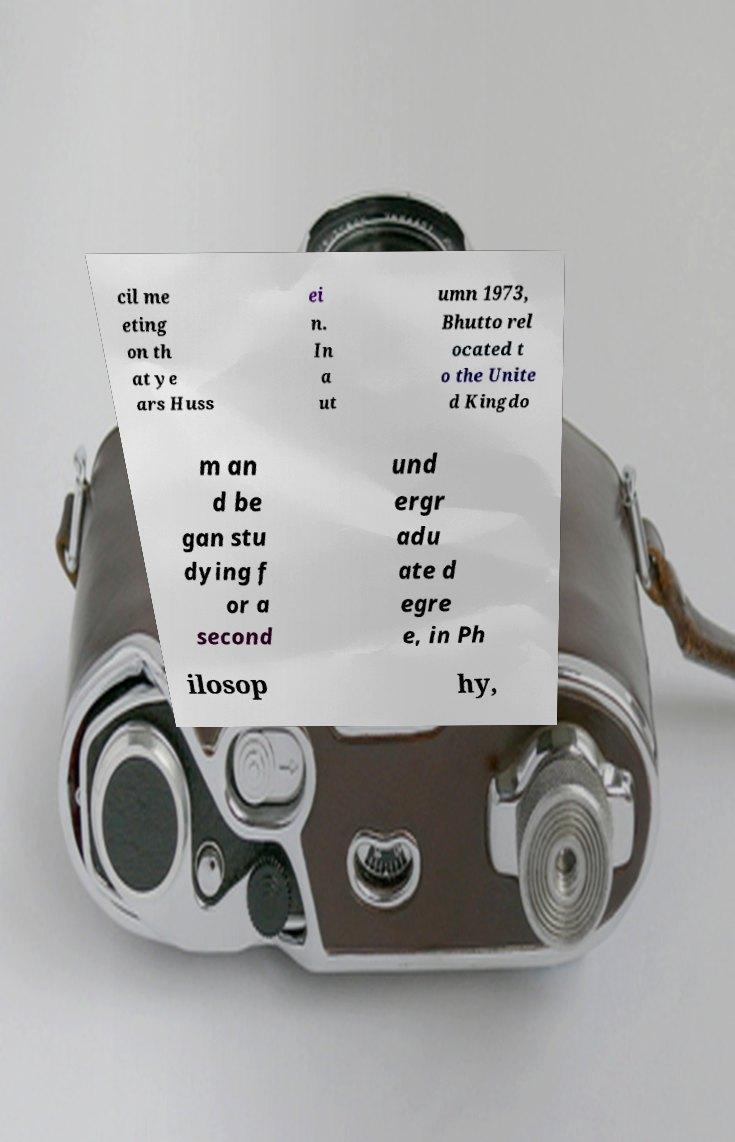There's text embedded in this image that I need extracted. Can you transcribe it verbatim? cil me eting on th at ye ars Huss ei n. In a ut umn 1973, Bhutto rel ocated t o the Unite d Kingdo m an d be gan stu dying f or a second und ergr adu ate d egre e, in Ph ilosop hy, 